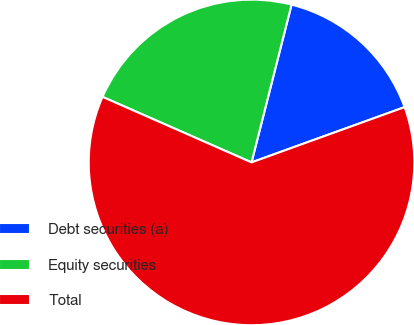Convert chart to OTSL. <chart><loc_0><loc_0><loc_500><loc_500><pie_chart><fcel>Debt securities (a)<fcel>Equity securities<fcel>Total<nl><fcel>15.53%<fcel>22.36%<fcel>62.11%<nl></chart> 